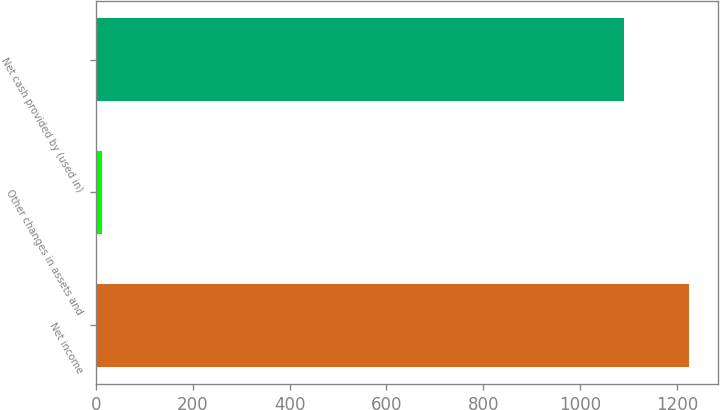Convert chart to OTSL. <chart><loc_0><loc_0><loc_500><loc_500><bar_chart><fcel>Net income<fcel>Other changes in assets and<fcel>Net cash provided by (used in)<nl><fcel>1224.45<fcel>13.2<fcel>1091.4<nl></chart> 